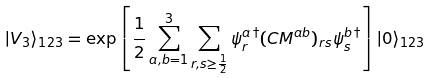<formula> <loc_0><loc_0><loc_500><loc_500>| V _ { 3 } \rangle _ { 1 2 3 } = \exp \left [ \frac { 1 } { 2 } \sum _ { a , b = 1 } ^ { 3 } \sum _ { r , s \geq \frac { 1 } { 2 } } \psi _ { r } ^ { a \, \dagger } ( C M ^ { a b } ) _ { r s } \psi _ { s } ^ { b \, \dagger } \right ] | 0 \rangle _ { 1 2 3 }</formula> 